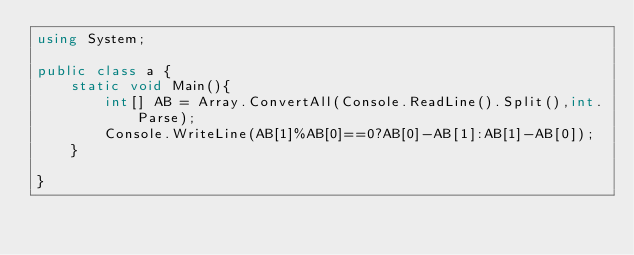Convert code to text. <code><loc_0><loc_0><loc_500><loc_500><_C#_>using System;

public class a {
	static void Main(){
    	int[] AB = Array.ConvertAll(Console.ReadLine().Split(),int.Parse);
      	Console.WriteLine(AB[1]%AB[0]==0?AB[0]-AB[1]:AB[1]-AB[0]);
    }

}
</code> 